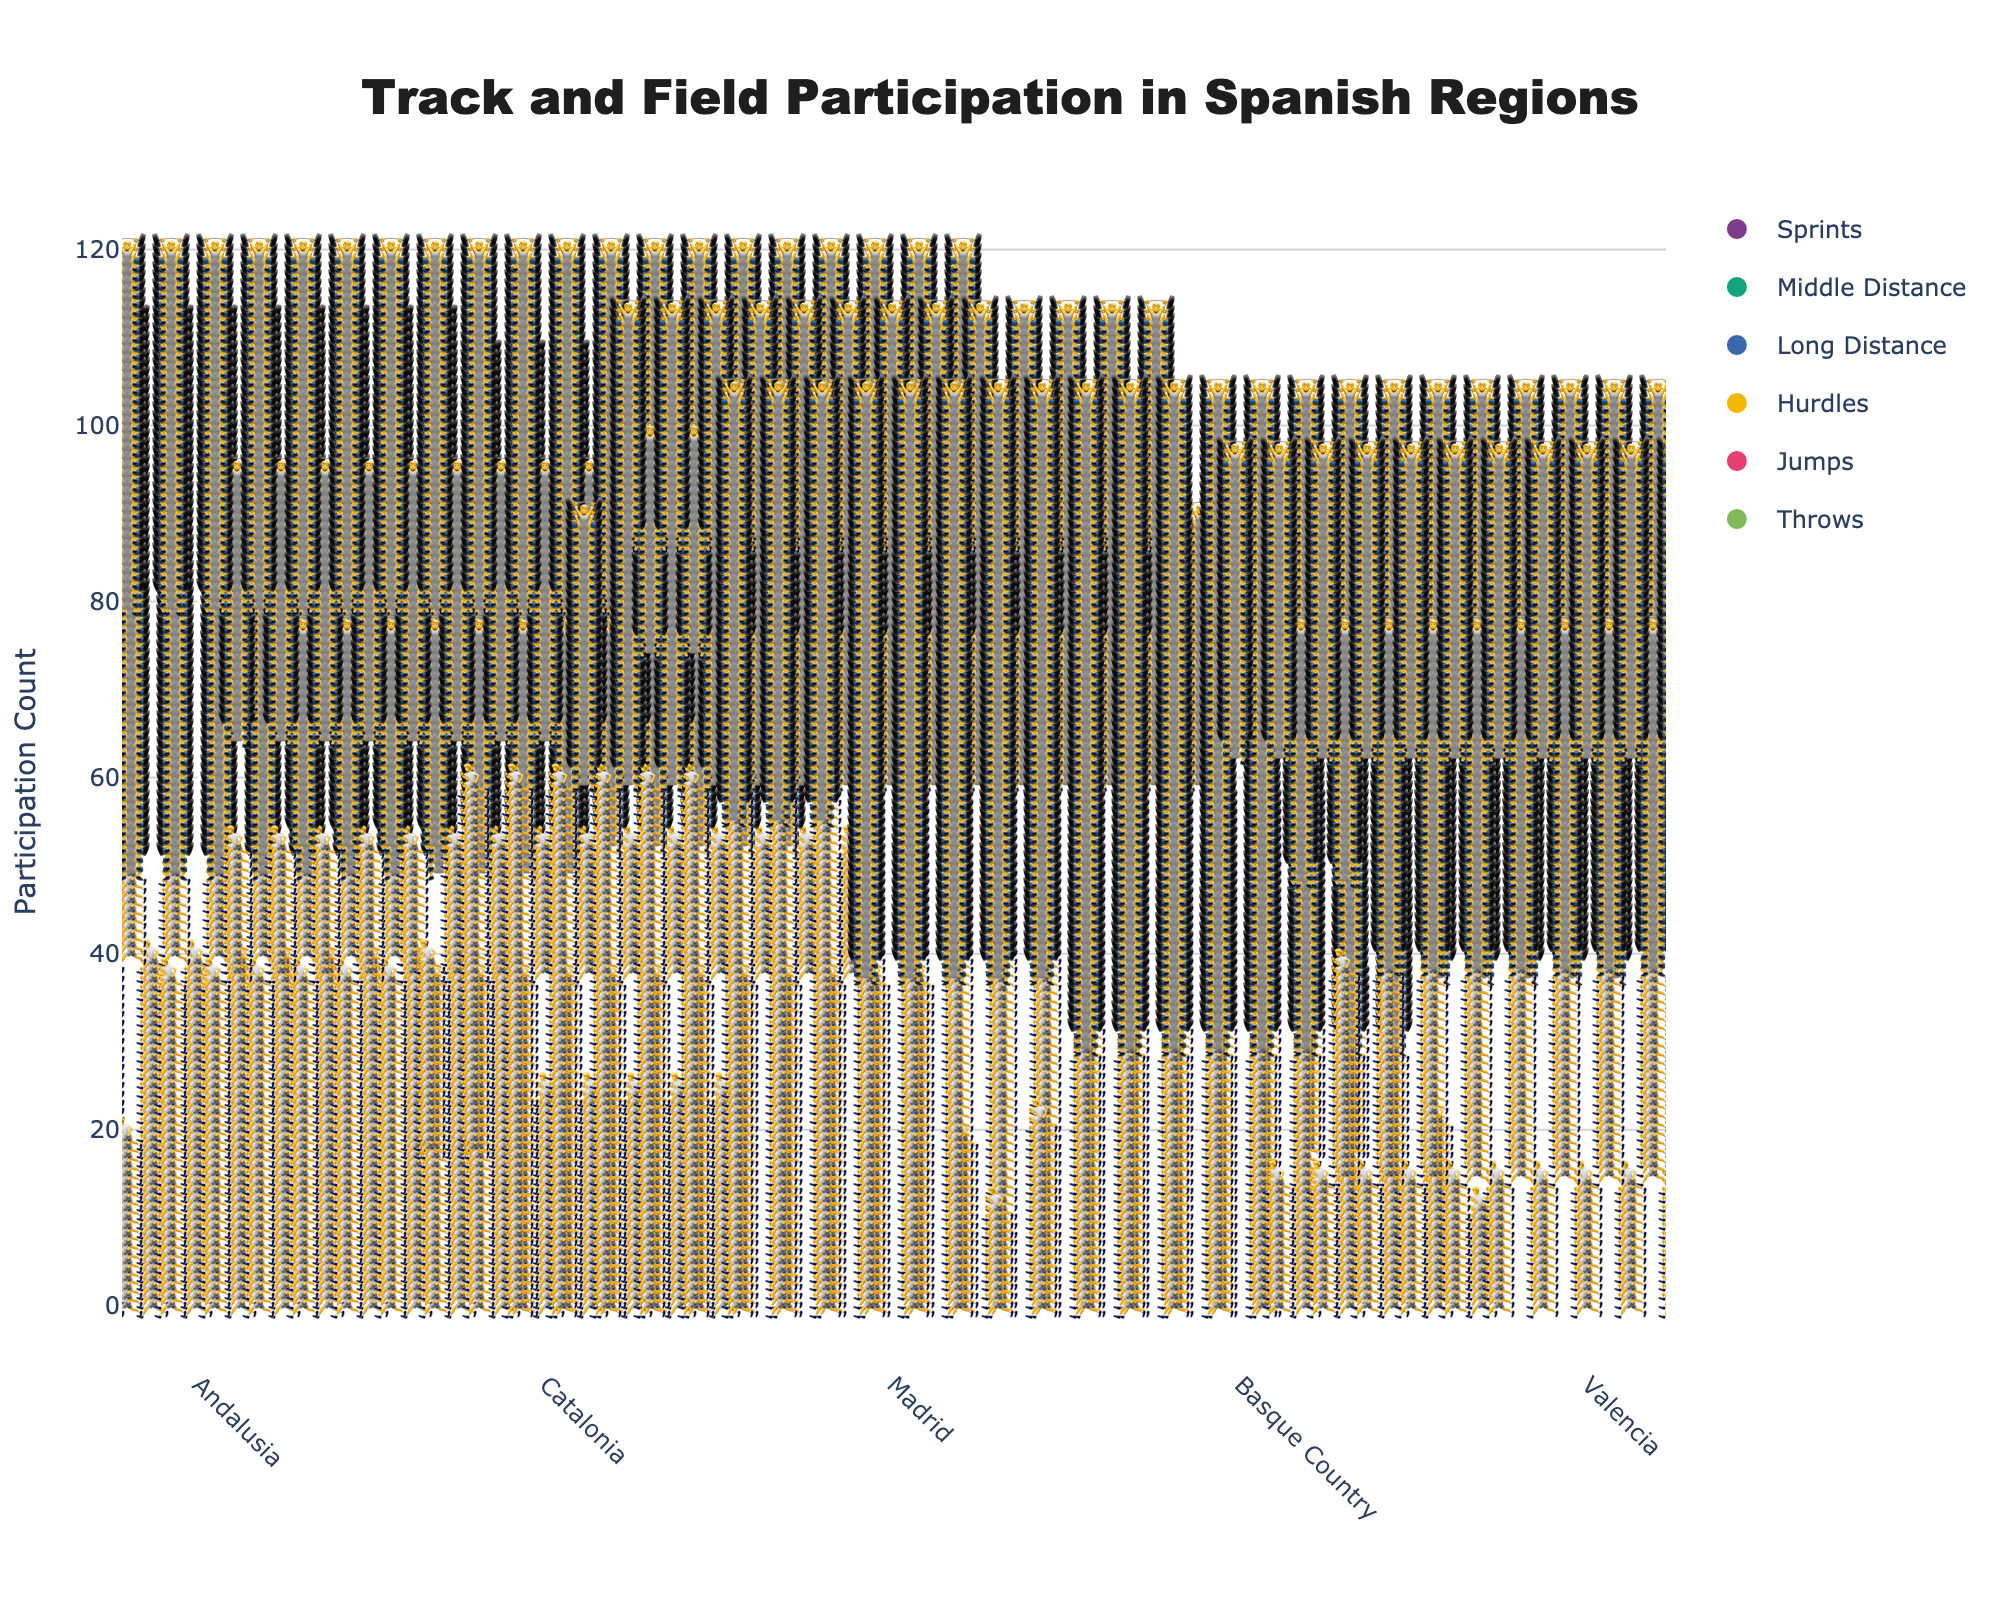What's the title of the figure? The title of a plot is generally displayed at the top in a larger font size for clear identification.
Answer: Track and Field Participation in Spanish Regions For which event does Andalusia have the highest participation? Look for the event under Andalusia column where the count is the highest. In this case, the maximum participation count for Andalusia is 25 in Sprints.
Answer: Sprints Which region has the highest participation in Throws? Look at the Throws row across all regions to find the region with the highest number. The region with the highest number in Throws is the Basque Country with 24.
Answer: Basque Country Compare the participation in Middle Distance events between Madrid and Valencia. Which one has higher participation and by how many? Find the participation values for Madrid and Valencia in the Middle Distance row. Subtract Valencia’s count from Madrid’s count. Madrid has 22 and Valencia has 12. 22 - 12 = 10.
Answer: Madrid by 10 What is the total participation across all regions in Long Distance events? Sum the participation counts for Long Distance events across all regions: 10 (Andalusia) + 15 (Catalonia) + 20 (Madrid) + 8 (Basque Country) + 12 (Valencia).
Answer: 65 Which region has the lowest participation in Jumps, and what is that value? Look at the Jumps row and identify the region with the lowest value. The lowest participation in Jumps is in Madrid with 12.
Answer: Madrid, 12 How much more is the participation in Hurdles in Andalusia compared to Basque Country? Subtract the Hurdles participation count of Basque Country from that of Andalusia. Andalusia has 18 and Basque Country has 8. 18 - 8 = 10.
Answer: 10 Which event has the highest total participation across all regions? Sum the participation counts for each event across all regions and identify the highest. Sprints: 25+20+18+12+15=90, Middle Distance: 15+18+22+10+12=77, Long Distance: 10+15+20+8+12=65, Hurdles: 18+12+15+8+10=63, Jumps: 20+15+12+18+14=79, Throws: 12+20+13+24+17=86. Sprints have the highest total with 90.
Answer: Sprints Does Catalonia have more participation in Sprints or Throws? Compare the numbers in the Sprints and Throws rows for Catalonia. Catalonia has 20 in Sprints and 20 in Throws.
Answer: Equal What is the overall average participation in Jumps for all regions? Sum the participation counts for Jumps across all regions and divide by the number of regions. (20 (Andalusia) + 15 (Catalonia) + 12 (Madrid) + 18 (Basque Country) + 14 (Valencia)) / 5 = 79 / 5 = 15.8.
Answer: 15.8 